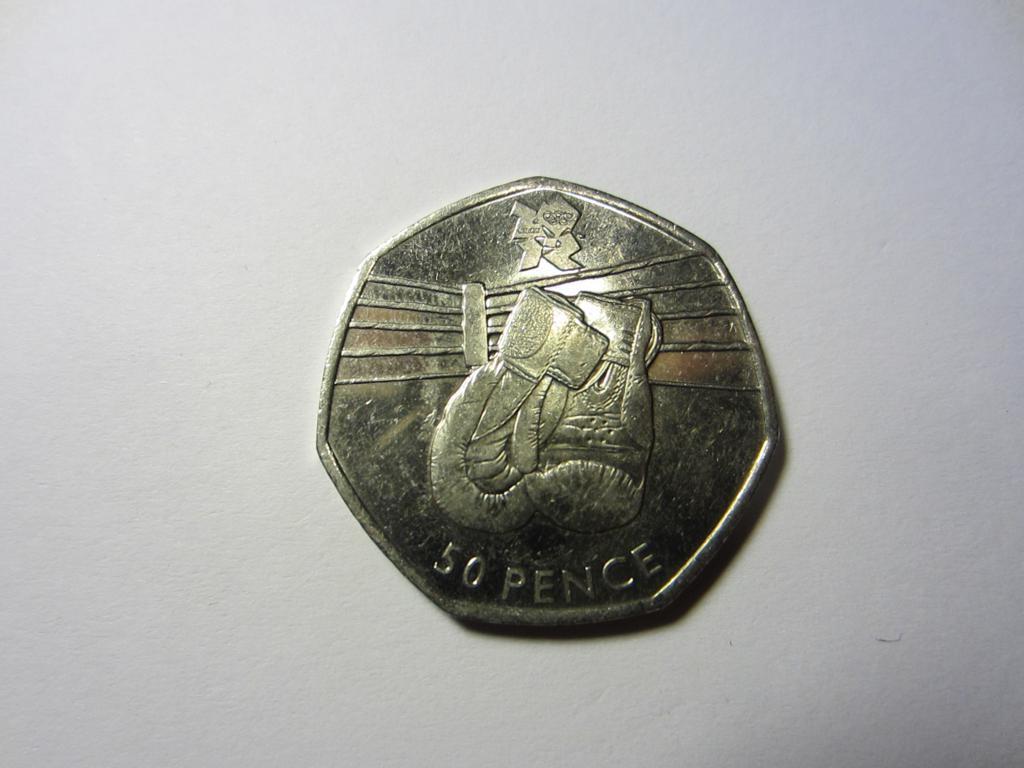How much is this coin worth?
Offer a very short reply. 50 pence. 